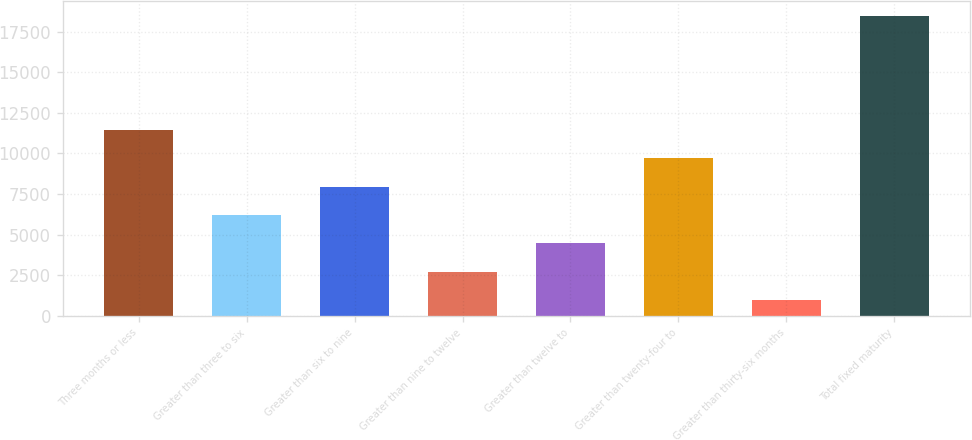<chart> <loc_0><loc_0><loc_500><loc_500><bar_chart><fcel>Three months or less<fcel>Greater than three to six<fcel>Greater than six to nine<fcel>Greater than nine to twelve<fcel>Greater than twelve to<fcel>Greater than twenty-four to<fcel>Greater than thirty-six months<fcel>Total fixed maturity<nl><fcel>11458.9<fcel>6215.5<fcel>7963.3<fcel>2719.9<fcel>4467.7<fcel>9711.1<fcel>972.1<fcel>18450.1<nl></chart> 